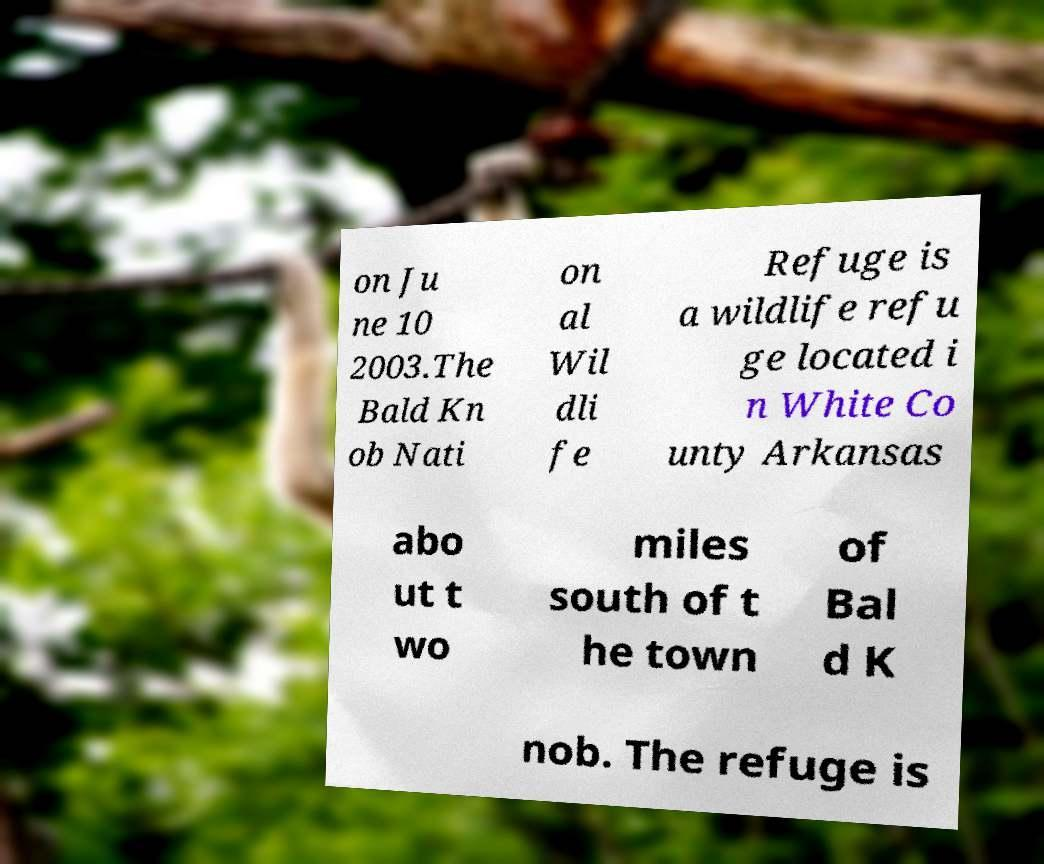Please identify and transcribe the text found in this image. on Ju ne 10 2003.The Bald Kn ob Nati on al Wil dli fe Refuge is a wildlife refu ge located i n White Co unty Arkansas abo ut t wo miles south of t he town of Bal d K nob. The refuge is 